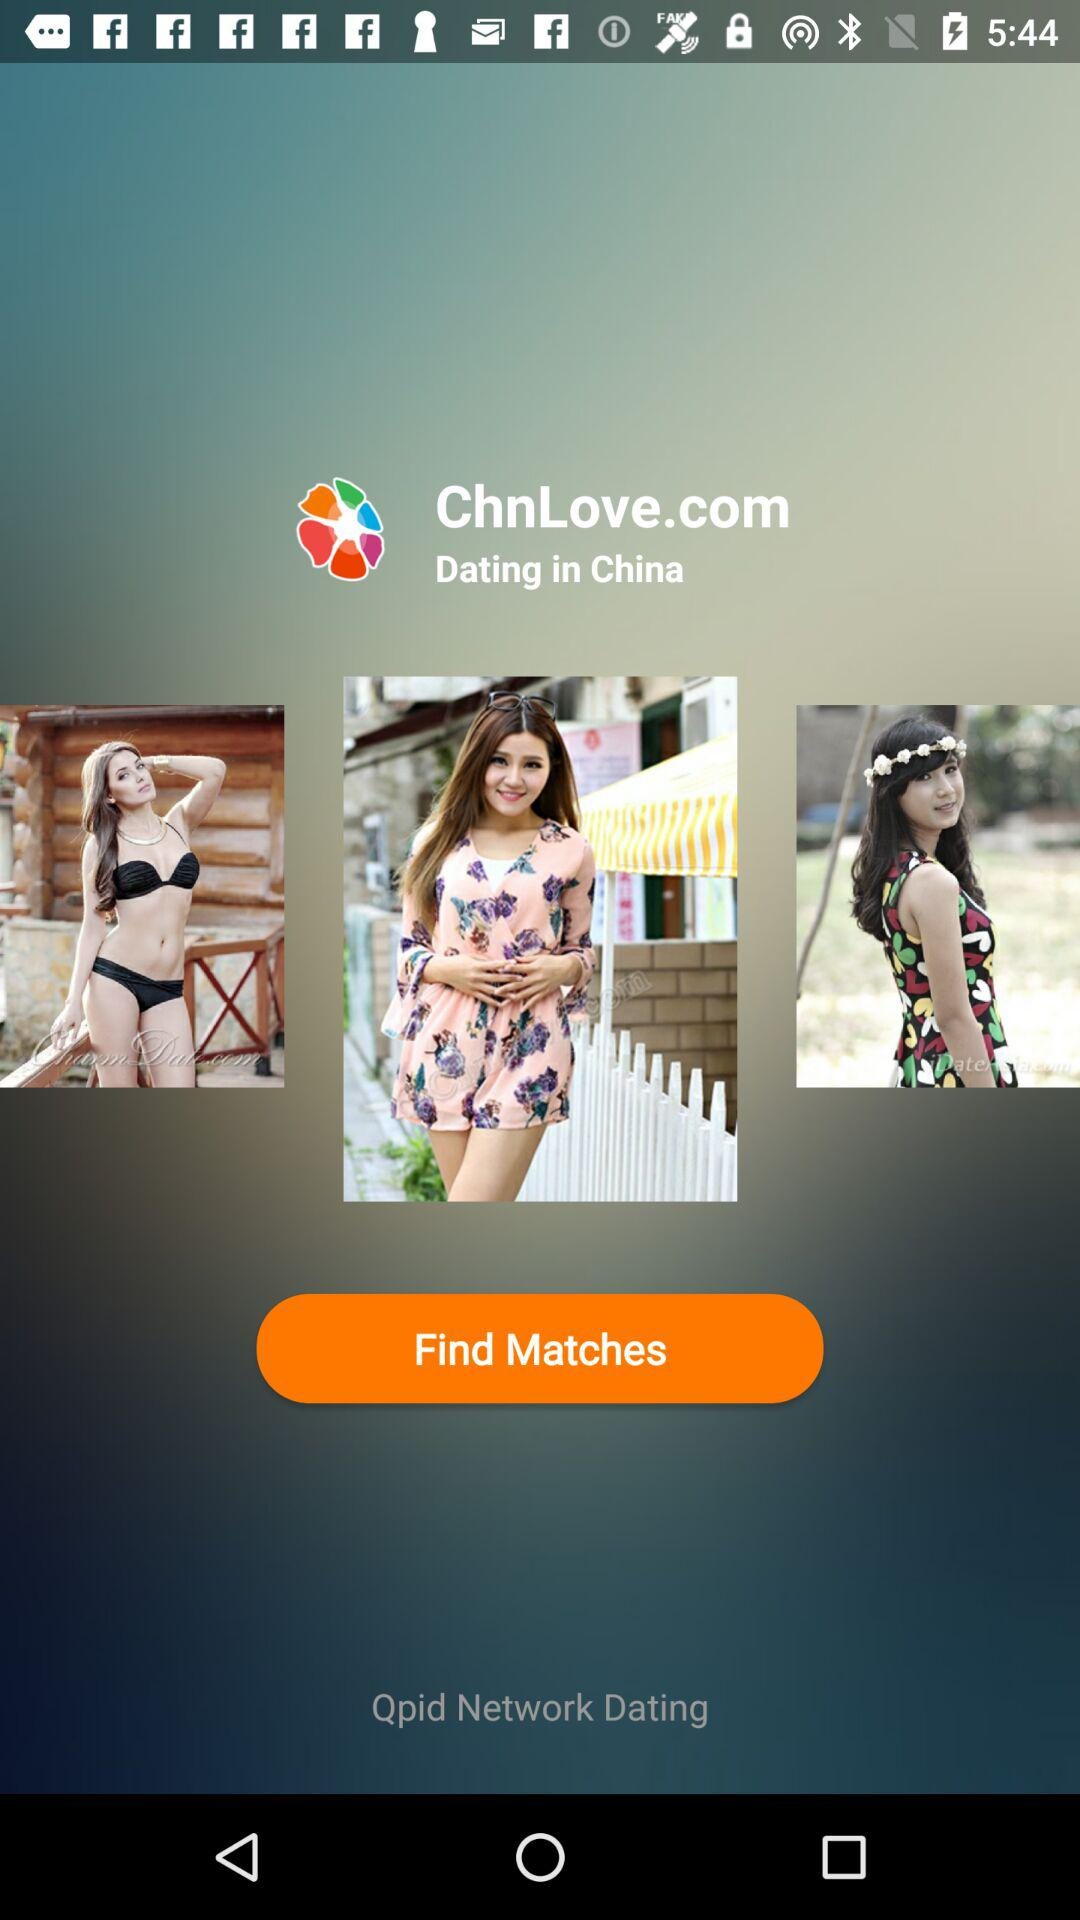What's the application name? The application name is "Qpid Network Dating". 